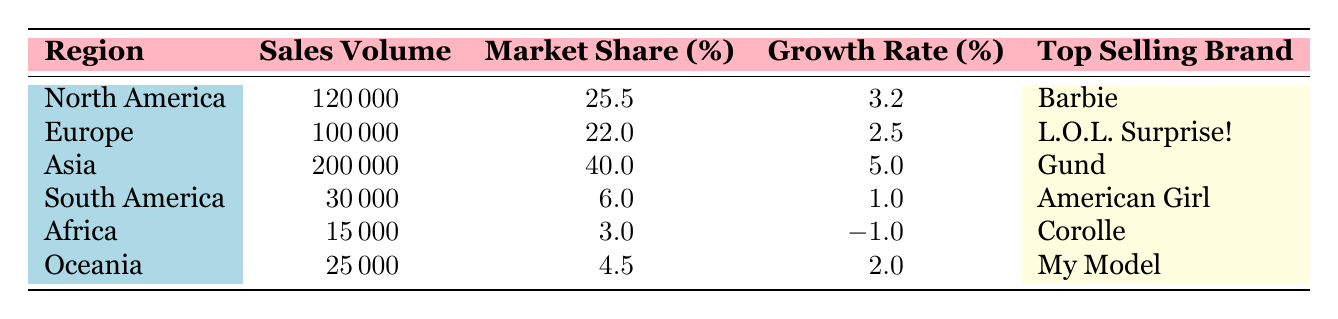What is the sales volume for North America? The sales volume for North America is listed directly in the table as 120000.
Answer: 120000 Which region has the highest market share percentage? By comparing the Market Share Percentage column, Asia shows the highest value at 40.0.
Answer: Asia Is the growth rate for Europe positive? The growth rate for Europe is 2.5, which is greater than zero indicating a positive growth rate.
Answer: Yes What is the average sales volume of all regions? The sales volumes are 120000, 100000, 200000, 30000, 15000, and 25000. Their sum is 478000. Dividing by the number of regions (6) gives an average sales volume of 79666.67 (approximately 79667).
Answer: 79667 Which region has the lowest growth rate? By looking at the Growth Rate column, Africa has a growth rate of -1.0, which is the lowest value compared to other regions.
Answer: Africa Do both South America and Oceania have a market share percentage above 5%? South America has a market share of 6.0, while Oceania has 4.5, so Oceania does not exceed 5%. Thus, not both regions meet the requirement.
Answer: No What is the combined sales volume for North America and Europe? The sales volumes for North America and Europe are 120000 and 100000, respectively. Their combined total is 120000 + 100000 = 220000.
Answer: 220000 Which brand is the top seller in Africa? The table lists Corolle as the top-selling brand in Africa.
Answer: Corolle Is the average growth rate across all regions greater than 2%? The growth rates are 3.2, 2.5, 5.0, 1.0, -1.0, and 2.0. Their sum is 12.7, so the average growth rate is 12.7 / 6 ≈ 2.12, which is greater than 2%.
Answer: Yes 